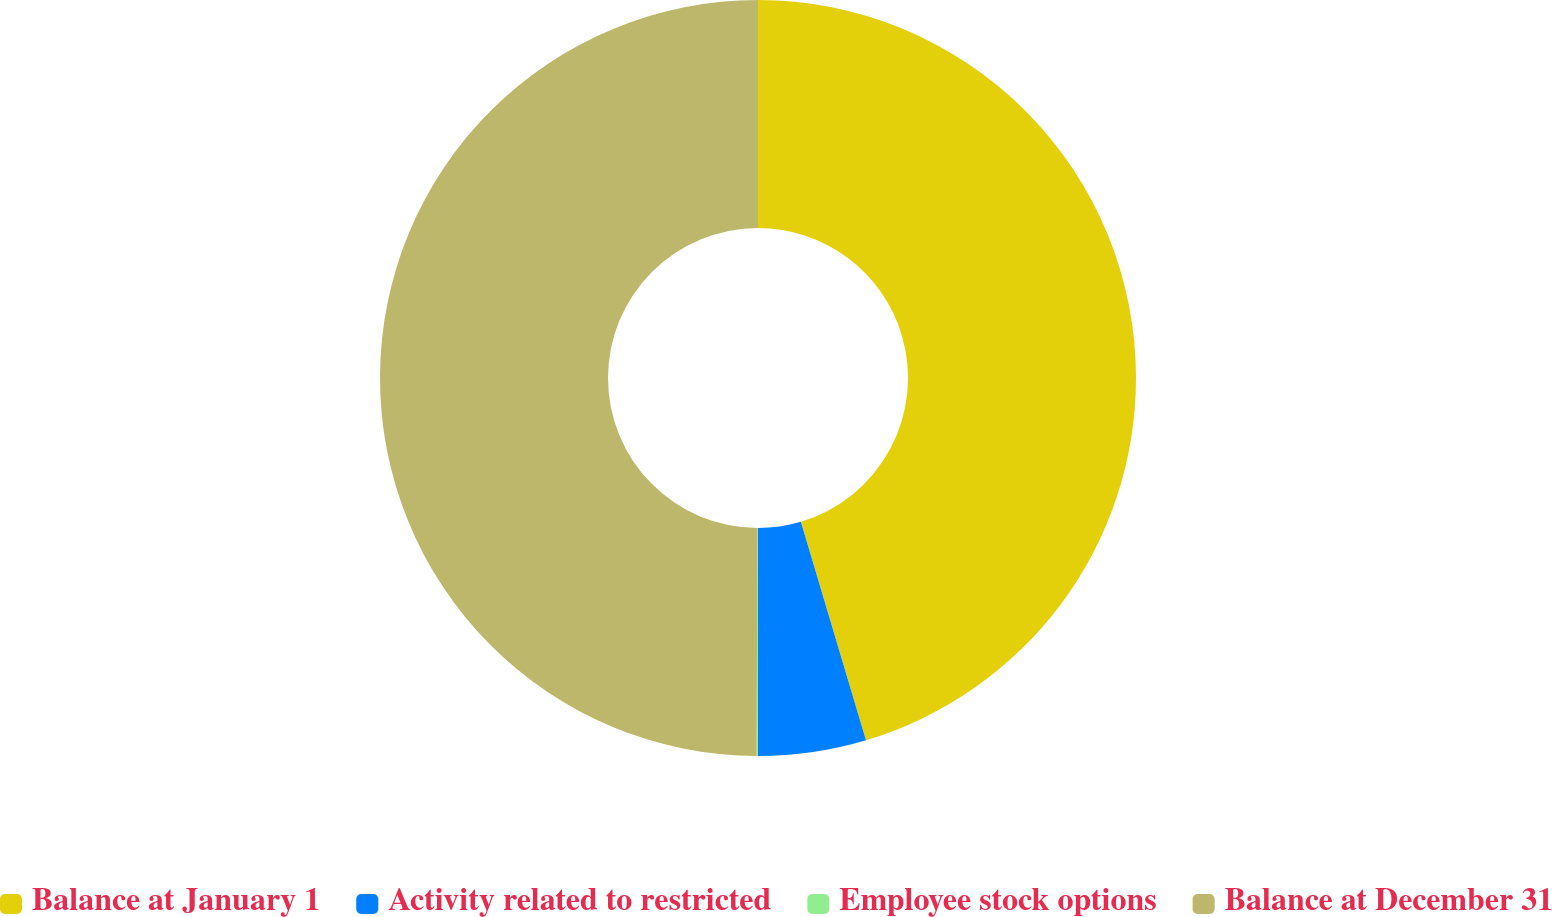Convert chart to OTSL. <chart><loc_0><loc_0><loc_500><loc_500><pie_chart><fcel>Balance at January 1<fcel>Activity related to restricted<fcel>Employee stock options<fcel>Balance at December 31<nl><fcel>45.39%<fcel>4.61%<fcel>0.06%<fcel>49.94%<nl></chart> 